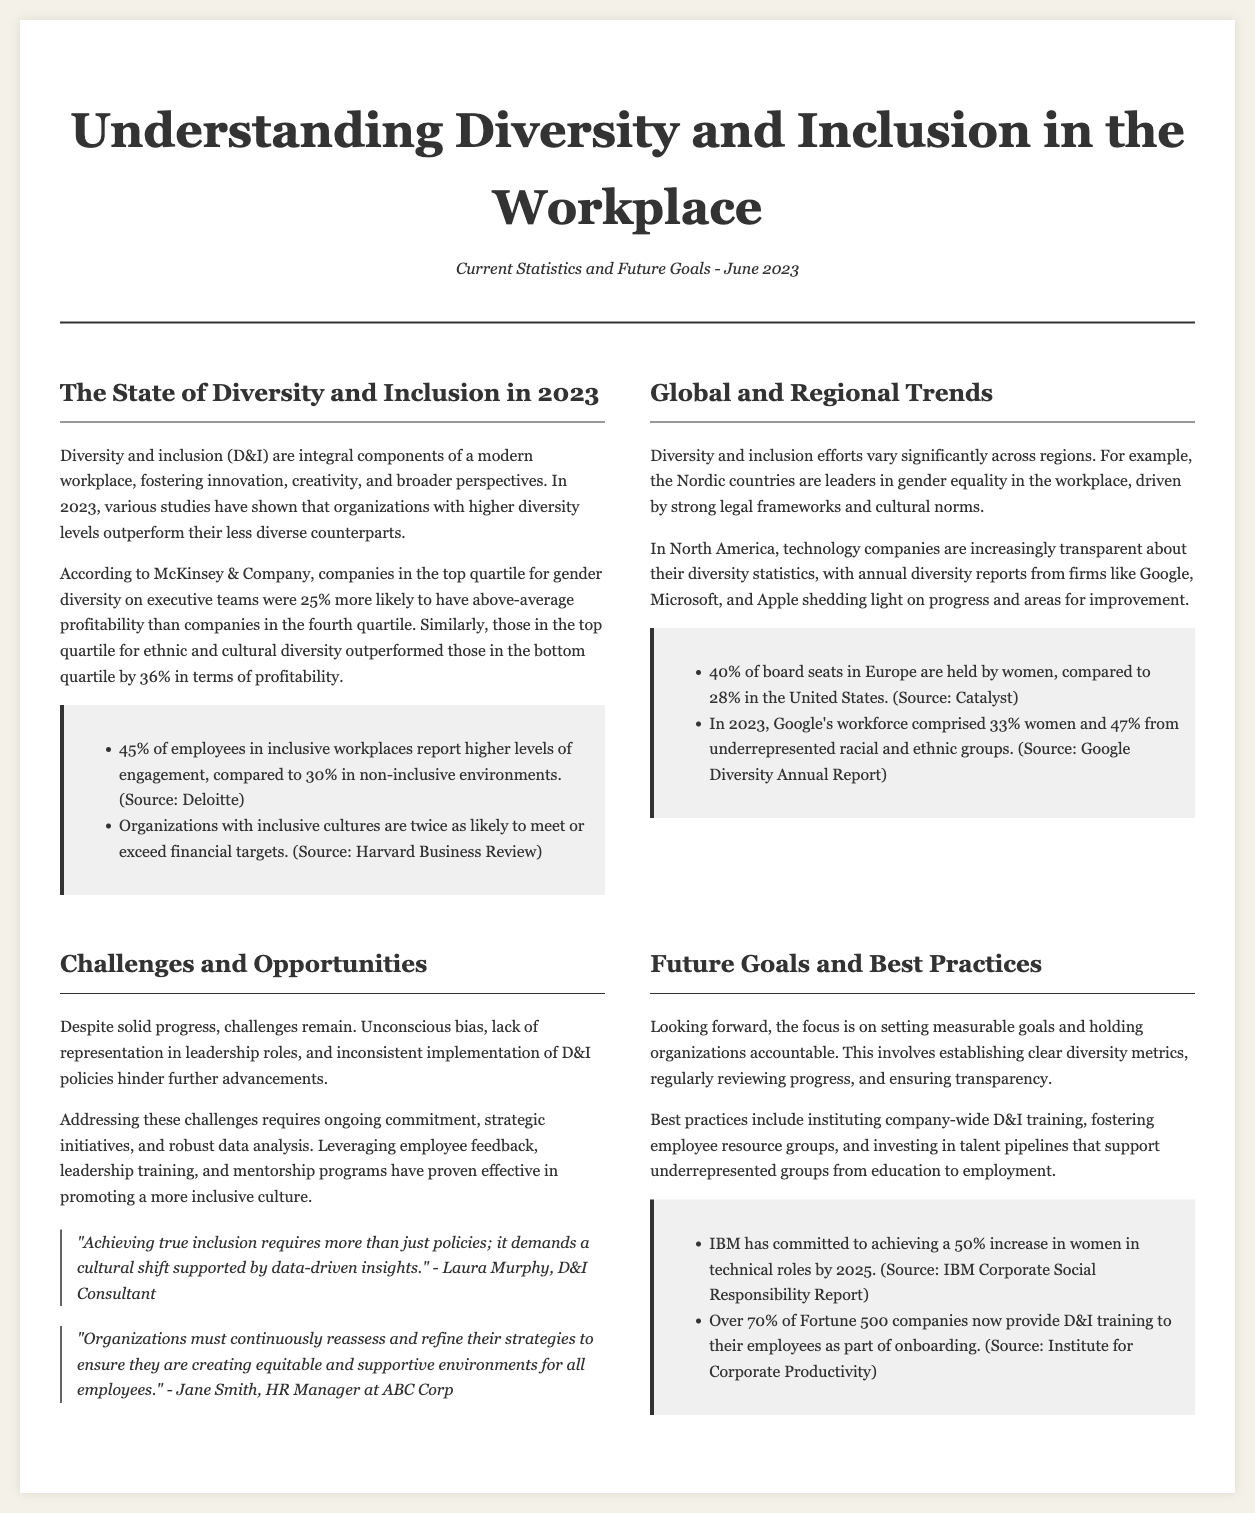What is the title of the document? The title of the document is indicated in the header section.
Answer: Understanding Diversity and Inclusion in the Workplace When was the document published? The publication date is shown below the title in the header.
Answer: June 2023 What percentage of employees in inclusive workplaces report higher engagement? This statistic is listed in the section highlighting diversity benefits.
Answer: 45% What is the percentage of board seats held by women in the United States? This information is part of the statistical data on global diversity trends.
Answer: 28% What company aims for a 50% increase in women in technical roles by 2025? This goal is mentioned in the section detailing future goals and best practices.
Answer: IBM What is a challenge mentioned regarding diversity and inclusion efforts? The challenges are discussed in the corresponding section of the document.
Answer: Unconscious bias How much more likely are organizations with inclusive cultures to meet or exceed financial targets? This information is provided in the statistics section discussing organizational performance.
Answer: Twice What is suggested as a best practice for promoting diversity? The document lists various strategies for enhancing diversity and inclusion culture.
Answer: D&I training 